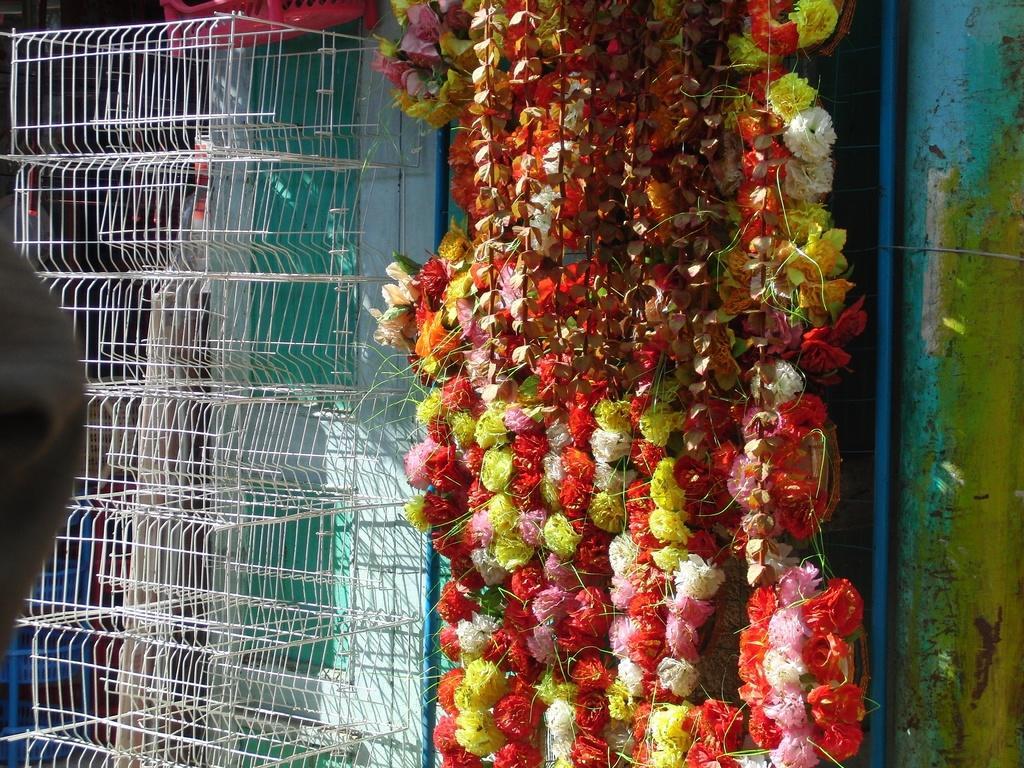Could you give a brief overview of what you see in this image? In this image, we can see some cages. There are flowers in the middle of the image. 